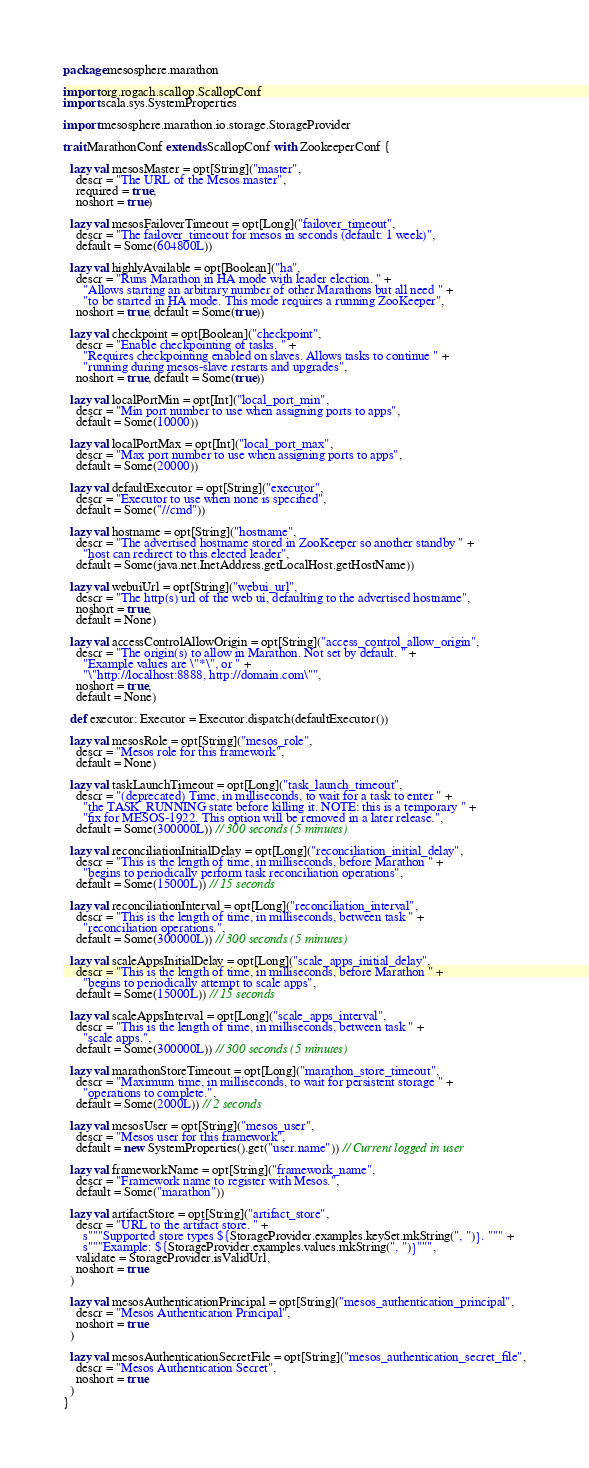Convert code to text. <code><loc_0><loc_0><loc_500><loc_500><_Scala_>package mesosphere.marathon

import org.rogach.scallop.ScallopConf
import scala.sys.SystemProperties

import mesosphere.marathon.io.storage.StorageProvider

trait MarathonConf extends ScallopConf with ZookeeperConf {

  lazy val mesosMaster = opt[String]("master",
    descr = "The URL of the Mesos master",
    required = true,
    noshort = true)

  lazy val mesosFailoverTimeout = opt[Long]("failover_timeout",
    descr = "The failover_timeout for mesos in seconds (default: 1 week)",
    default = Some(604800L))

  lazy val highlyAvailable = opt[Boolean]("ha",
    descr = "Runs Marathon in HA mode with leader election. " +
      "Allows starting an arbitrary number of other Marathons but all need " +
      "to be started in HA mode. This mode requires a running ZooKeeper",
    noshort = true, default = Some(true))

  lazy val checkpoint = opt[Boolean]("checkpoint",
    descr = "Enable checkpointing of tasks. " +
      "Requires checkpointing enabled on slaves. Allows tasks to continue " +
      "running during mesos-slave restarts and upgrades",
    noshort = true, default = Some(true))

  lazy val localPortMin = opt[Int]("local_port_min",
    descr = "Min port number to use when assigning ports to apps",
    default = Some(10000))

  lazy val localPortMax = opt[Int]("local_port_max",
    descr = "Max port number to use when assigning ports to apps",
    default = Some(20000))

  lazy val defaultExecutor = opt[String]("executor",
    descr = "Executor to use when none is specified",
    default = Some("//cmd"))

  lazy val hostname = opt[String]("hostname",
    descr = "The advertised hostname stored in ZooKeeper so another standby " +
      "host can redirect to this elected leader",
    default = Some(java.net.InetAddress.getLocalHost.getHostName))

  lazy val webuiUrl = opt[String]("webui_url",
    descr = "The http(s) url of the web ui, defaulting to the advertised hostname",
    noshort = true,
    default = None)

  lazy val accessControlAllowOrigin = opt[String]("access_control_allow_origin",
    descr = "The origin(s) to allow in Marathon. Not set by default. " +
      "Example values are \"*\", or " +
      "\"http://localhost:8888, http://domain.com\"",
    noshort = true,
    default = None)

  def executor: Executor = Executor.dispatch(defaultExecutor())

  lazy val mesosRole = opt[String]("mesos_role",
    descr = "Mesos role for this framework",
    default = None)

  lazy val taskLaunchTimeout = opt[Long]("task_launch_timeout",
    descr = "(deprecated) Time, in milliseconds, to wait for a task to enter " +
      "the TASK_RUNNING state before killing it. NOTE: this is a temporary " +
      "fix for MESOS-1922. This option will be removed in a later release.",
    default = Some(300000L)) // 300 seconds (5 minutes)

  lazy val reconciliationInitialDelay = opt[Long]("reconciliation_initial_delay",
    descr = "This is the length of time, in milliseconds, before Marathon " +
      "begins to periodically perform task reconciliation operations",
    default = Some(15000L)) // 15 seconds

  lazy val reconciliationInterval = opt[Long]("reconciliation_interval",
    descr = "This is the length of time, in milliseconds, between task " +
      "reconciliation operations.",
    default = Some(300000L)) // 300 seconds (5 minutes)

  lazy val scaleAppsInitialDelay = opt[Long]("scale_apps_initial_delay",
    descr = "This is the length of time, in milliseconds, before Marathon " +
      "begins to periodically attempt to scale apps",
    default = Some(15000L)) // 15 seconds

  lazy val scaleAppsInterval = opt[Long]("scale_apps_interval",
    descr = "This is the length of time, in milliseconds, between task " +
      "scale apps.",
    default = Some(300000L)) // 300 seconds (5 minutes)

  lazy val marathonStoreTimeout = opt[Long]("marathon_store_timeout",
    descr = "Maximum time, in milliseconds, to wait for persistent storage " +
      "operations to complete.",
    default = Some(2000L)) // 2 seconds

  lazy val mesosUser = opt[String]("mesos_user",
    descr = "Mesos user for this framework",
    default = new SystemProperties().get("user.name")) // Current logged in user

  lazy val frameworkName = opt[String]("framework_name",
    descr = "Framework name to register with Mesos.",
    default = Some("marathon"))

  lazy val artifactStore = opt[String]("artifact_store",
    descr = "URL to the artifact store. " +
      s"""Supported store types ${StorageProvider.examples.keySet.mkString(", ")}. """ +
      s"""Example: ${StorageProvider.examples.values.mkString(", ")}""",
    validate = StorageProvider.isValidUrl,
    noshort = true
  )

  lazy val mesosAuthenticationPrincipal = opt[String]("mesos_authentication_principal",
    descr = "Mesos Authentication Principal",
    noshort = true
  )

  lazy val mesosAuthenticationSecretFile = opt[String]("mesos_authentication_secret_file",
    descr = "Mesos Authentication Secret",
    noshort = true
  )
}
</code> 